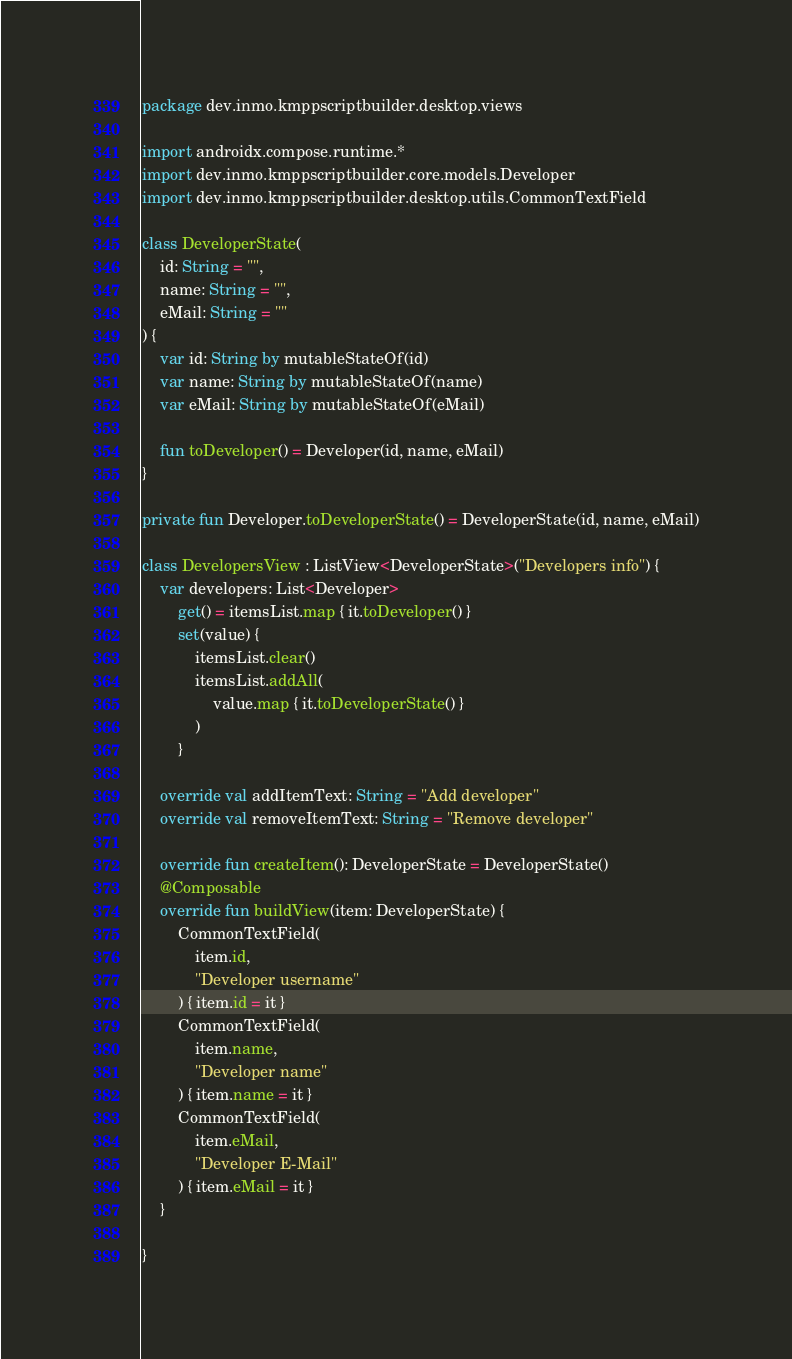Convert code to text. <code><loc_0><loc_0><loc_500><loc_500><_Kotlin_>package dev.inmo.kmppscriptbuilder.desktop.views

import androidx.compose.runtime.*
import dev.inmo.kmppscriptbuilder.core.models.Developer
import dev.inmo.kmppscriptbuilder.desktop.utils.CommonTextField

class DeveloperState(
    id: String = "",
    name: String = "",
    eMail: String = ""
) {
    var id: String by mutableStateOf(id)
    var name: String by mutableStateOf(name)
    var eMail: String by mutableStateOf(eMail)

    fun toDeveloper() = Developer(id, name, eMail)
}

private fun Developer.toDeveloperState() = DeveloperState(id, name, eMail)

class DevelopersView : ListView<DeveloperState>("Developers info") {
    var developers: List<Developer>
        get() = itemsList.map { it.toDeveloper() }
        set(value) {
            itemsList.clear()
            itemsList.addAll(
                value.map { it.toDeveloperState() }
            )
        }

    override val addItemText: String = "Add developer"
    override val removeItemText: String = "Remove developer"

    override fun createItem(): DeveloperState = DeveloperState()
    @Composable
    override fun buildView(item: DeveloperState) {
        CommonTextField(
            item.id,
            "Developer username"
        ) { item.id = it }
        CommonTextField(
            item.name,
            "Developer name"
        ) { item.name = it }
        CommonTextField(
            item.eMail,
            "Developer E-Mail"
        ) { item.eMail = it }
    }

}
</code> 